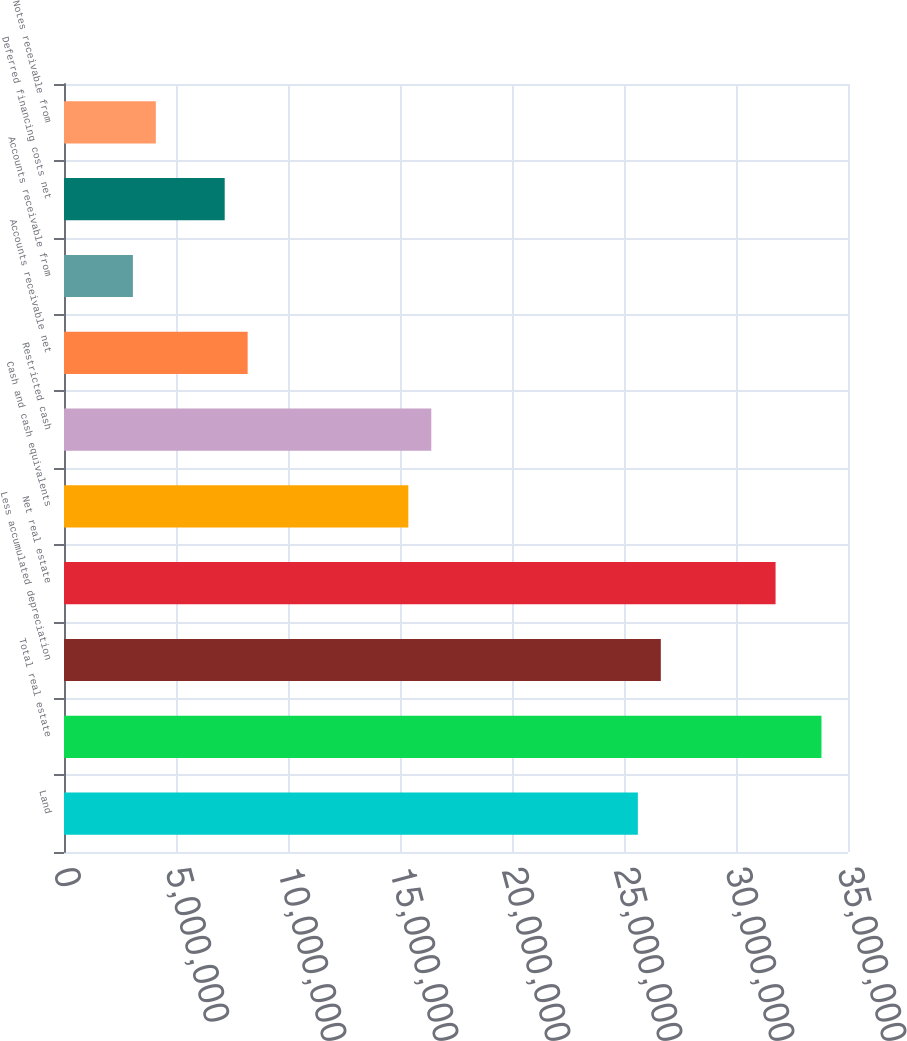Convert chart. <chart><loc_0><loc_0><loc_500><loc_500><bar_chart><fcel>Land<fcel>Total real estate<fcel>Less accumulated depreciation<fcel>Net real estate<fcel>Cash and cash equivalents<fcel>Restricted cash<fcel>Accounts receivable net<fcel>Accounts receivable from<fcel>Deferred financing costs net<fcel>Notes receivable from<nl><fcel>2.56187e+07<fcel>3.38162e+07<fcel>2.66433e+07<fcel>3.17668e+07<fcel>1.53717e+07<fcel>1.63964e+07<fcel>8.19889e+06<fcel>3.07543e+06<fcel>7.1742e+06<fcel>4.10012e+06<nl></chart> 